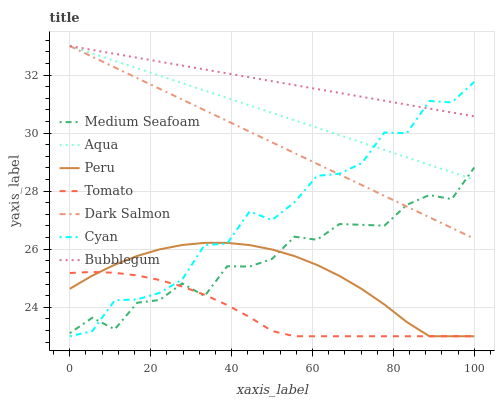Does Tomato have the minimum area under the curve?
Answer yes or no. Yes. Does Bubblegum have the maximum area under the curve?
Answer yes or no. Yes. Does Aqua have the minimum area under the curve?
Answer yes or no. No. Does Aqua have the maximum area under the curve?
Answer yes or no. No. Is Aqua the smoothest?
Answer yes or no. Yes. Is Cyan the roughest?
Answer yes or no. Yes. Is Dark Salmon the smoothest?
Answer yes or no. No. Is Dark Salmon the roughest?
Answer yes or no. No. Does Tomato have the lowest value?
Answer yes or no. Yes. Does Aqua have the lowest value?
Answer yes or no. No. Does Bubblegum have the highest value?
Answer yes or no. Yes. Does Peru have the highest value?
Answer yes or no. No. Is Peru less than Dark Salmon?
Answer yes or no. Yes. Is Bubblegum greater than Tomato?
Answer yes or no. Yes. Does Cyan intersect Dark Salmon?
Answer yes or no. Yes. Is Cyan less than Dark Salmon?
Answer yes or no. No. Is Cyan greater than Dark Salmon?
Answer yes or no. No. Does Peru intersect Dark Salmon?
Answer yes or no. No. 